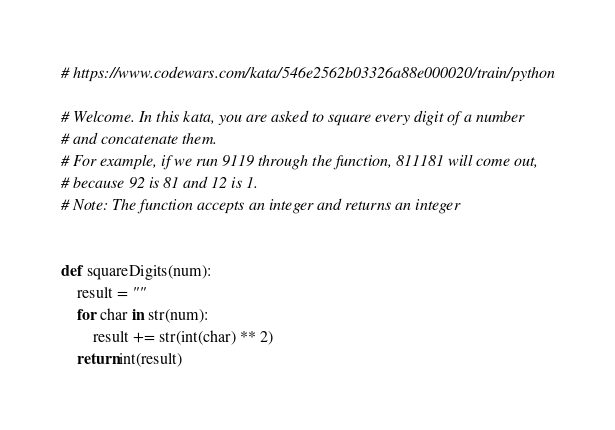Convert code to text. <code><loc_0><loc_0><loc_500><loc_500><_Python_># https://www.codewars.com/kata/546e2562b03326a88e000020/train/python

# Welcome. In this kata, you are asked to square every digit of a number
# and concatenate them.
# For example, if we run 9119 through the function, 811181 will come out,
# because 92 is 81 and 12 is 1.
# Note: The function accepts an integer and returns an integer


def squareDigits(num):
    result = ""
    for char in str(num):
        result += str(int(char) ** 2)
    return int(result)
</code> 